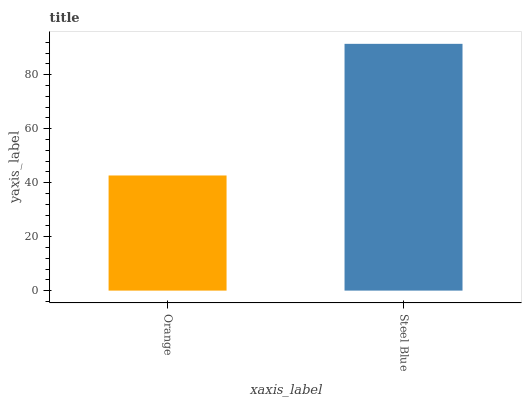Is Steel Blue the minimum?
Answer yes or no. No. Is Steel Blue greater than Orange?
Answer yes or no. Yes. Is Orange less than Steel Blue?
Answer yes or no. Yes. Is Orange greater than Steel Blue?
Answer yes or no. No. Is Steel Blue less than Orange?
Answer yes or no. No. Is Steel Blue the high median?
Answer yes or no. Yes. Is Orange the low median?
Answer yes or no. Yes. Is Orange the high median?
Answer yes or no. No. Is Steel Blue the low median?
Answer yes or no. No. 